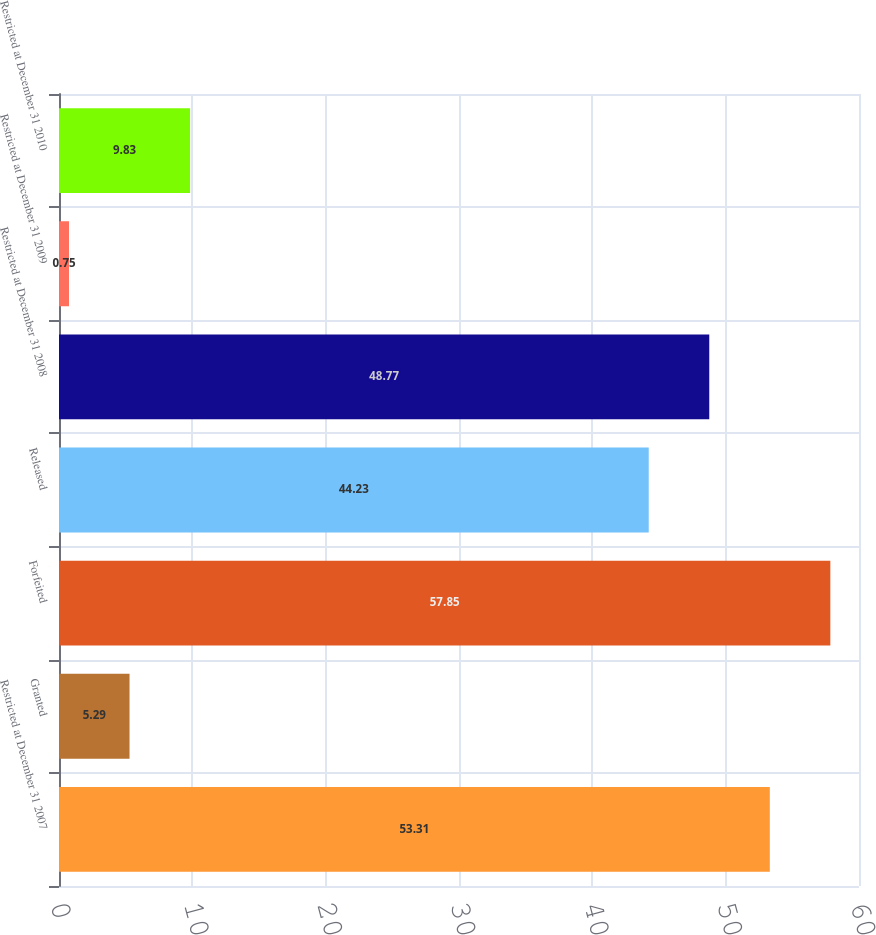<chart> <loc_0><loc_0><loc_500><loc_500><bar_chart><fcel>Restricted at December 31 2007<fcel>Granted<fcel>Forfeited<fcel>Released<fcel>Restricted at December 31 2008<fcel>Restricted at December 31 2009<fcel>Restricted at December 31 2010<nl><fcel>53.31<fcel>5.29<fcel>57.85<fcel>44.23<fcel>48.77<fcel>0.75<fcel>9.83<nl></chart> 